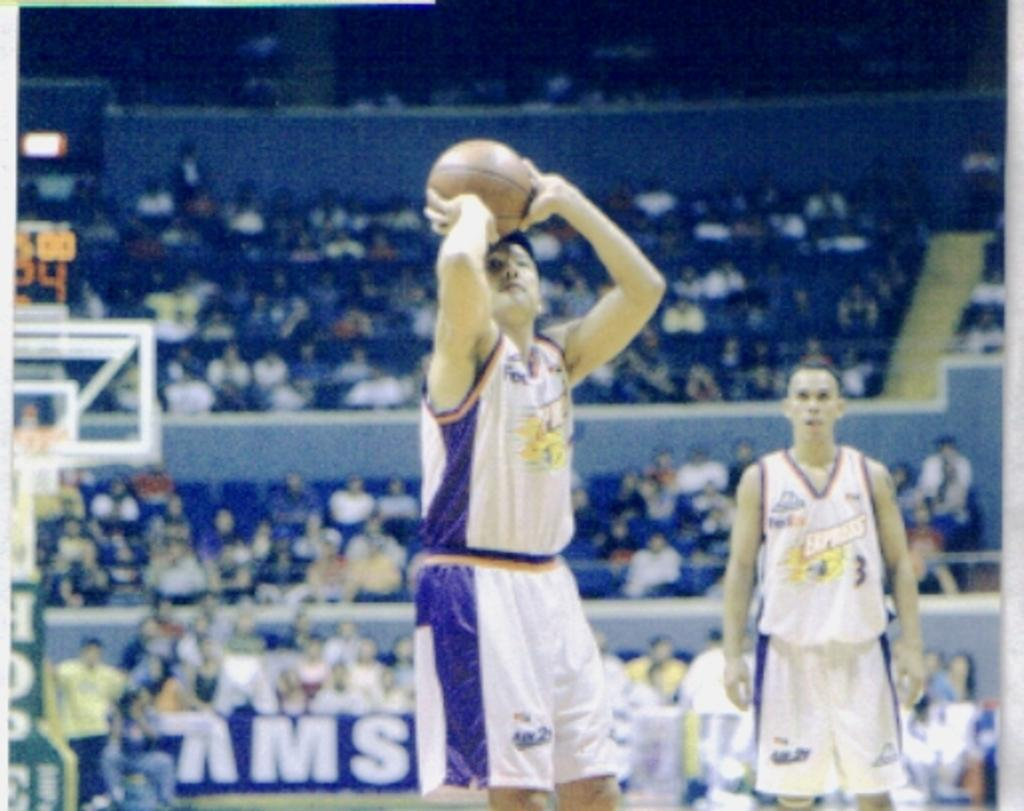What activity are the people in the foreground of the image engaged in? The people in the foreground of the image are playing with a ball. What can be seen in the background of the image? There are people sitting in a stadium in the background of the image. What are the people in the stadium doing? The people in the stadium are watching a game. What type of beef is being served to the players during the game? There is no mention of beef or any food being served in the image. What is the relation between the people playing with the ball and the people in the stadium? The image does not provide information about the relationship between the people playing with the ball and the people in the stadium. 